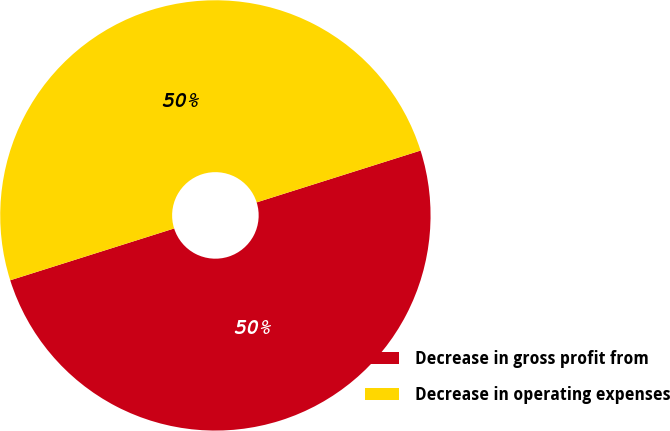Convert chart to OTSL. <chart><loc_0><loc_0><loc_500><loc_500><pie_chart><fcel>Decrease in gross profit from<fcel>Decrease in operating expenses<nl><fcel>50.0%<fcel>50.0%<nl></chart> 